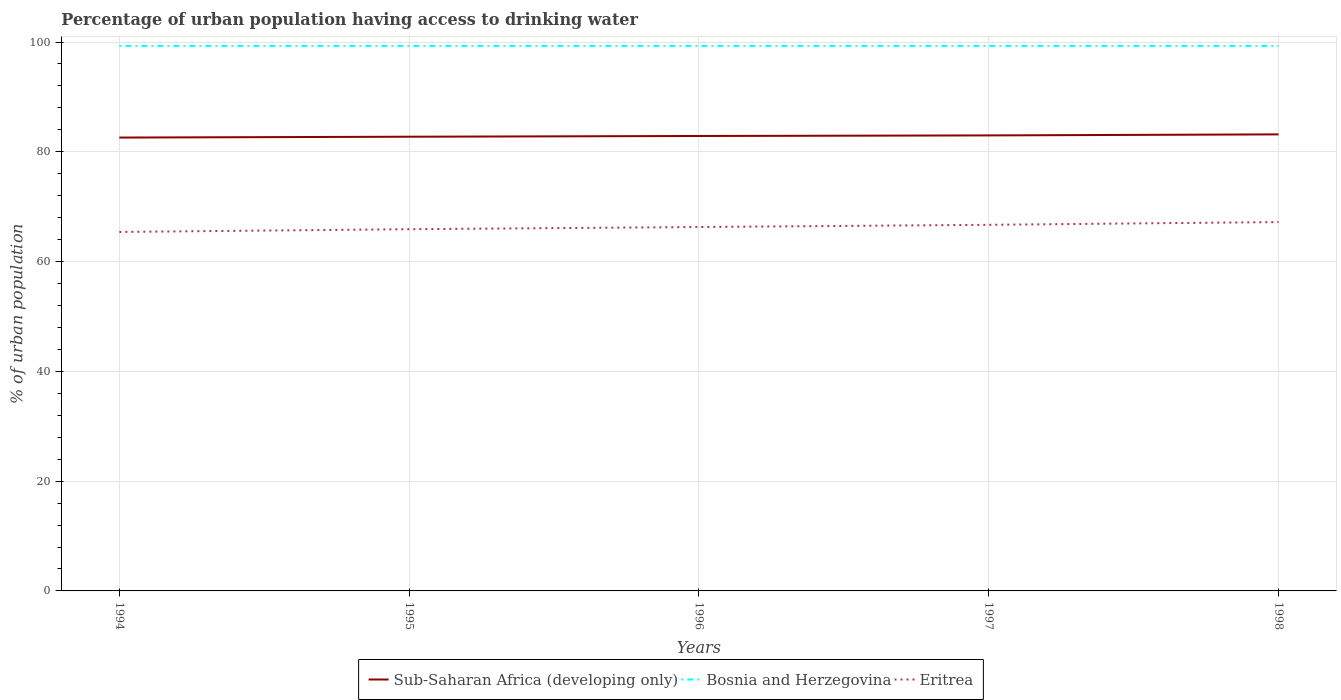How many different coloured lines are there?
Provide a short and direct response. 3. Does the line corresponding to Sub-Saharan Africa (developing only) intersect with the line corresponding to Bosnia and Herzegovina?
Offer a terse response. No. Across all years, what is the maximum percentage of urban population having access to drinking water in Eritrea?
Your answer should be very brief. 65.4. In which year was the percentage of urban population having access to drinking water in Eritrea maximum?
Offer a very short reply. 1994. What is the total percentage of urban population having access to drinking water in Eritrea in the graph?
Ensure brevity in your answer.  -1.3. What is the difference between the highest and the second highest percentage of urban population having access to drinking water in Bosnia and Herzegovina?
Provide a succinct answer. 0. How many years are there in the graph?
Keep it short and to the point. 5. What is the difference between two consecutive major ticks on the Y-axis?
Provide a short and direct response. 20. Are the values on the major ticks of Y-axis written in scientific E-notation?
Your response must be concise. No. Does the graph contain any zero values?
Offer a terse response. No. Where does the legend appear in the graph?
Your response must be concise. Bottom center. What is the title of the graph?
Offer a very short reply. Percentage of urban population having access to drinking water. Does "Sub-Saharan Africa (all income levels)" appear as one of the legend labels in the graph?
Give a very brief answer. No. What is the label or title of the X-axis?
Offer a terse response. Years. What is the label or title of the Y-axis?
Make the answer very short. % of urban population. What is the % of urban population in Sub-Saharan Africa (developing only) in 1994?
Your response must be concise. 82.6. What is the % of urban population of Bosnia and Herzegovina in 1994?
Your answer should be compact. 99.3. What is the % of urban population in Eritrea in 1994?
Offer a very short reply. 65.4. What is the % of urban population in Sub-Saharan Africa (developing only) in 1995?
Offer a terse response. 82.75. What is the % of urban population in Bosnia and Herzegovina in 1995?
Ensure brevity in your answer.  99.3. What is the % of urban population in Eritrea in 1995?
Offer a terse response. 65.9. What is the % of urban population of Sub-Saharan Africa (developing only) in 1996?
Provide a succinct answer. 82.88. What is the % of urban population of Bosnia and Herzegovina in 1996?
Offer a very short reply. 99.3. What is the % of urban population in Eritrea in 1996?
Offer a terse response. 66.3. What is the % of urban population of Sub-Saharan Africa (developing only) in 1997?
Give a very brief answer. 82.99. What is the % of urban population in Bosnia and Herzegovina in 1997?
Give a very brief answer. 99.3. What is the % of urban population of Eritrea in 1997?
Offer a terse response. 66.7. What is the % of urban population of Sub-Saharan Africa (developing only) in 1998?
Your response must be concise. 83.18. What is the % of urban population of Bosnia and Herzegovina in 1998?
Provide a short and direct response. 99.3. What is the % of urban population in Eritrea in 1998?
Make the answer very short. 67.2. Across all years, what is the maximum % of urban population of Sub-Saharan Africa (developing only)?
Offer a terse response. 83.18. Across all years, what is the maximum % of urban population of Bosnia and Herzegovina?
Your answer should be compact. 99.3. Across all years, what is the maximum % of urban population of Eritrea?
Provide a succinct answer. 67.2. Across all years, what is the minimum % of urban population of Sub-Saharan Africa (developing only)?
Ensure brevity in your answer.  82.6. Across all years, what is the minimum % of urban population of Bosnia and Herzegovina?
Provide a short and direct response. 99.3. Across all years, what is the minimum % of urban population of Eritrea?
Offer a very short reply. 65.4. What is the total % of urban population of Sub-Saharan Africa (developing only) in the graph?
Keep it short and to the point. 414.4. What is the total % of urban population of Bosnia and Herzegovina in the graph?
Provide a short and direct response. 496.5. What is the total % of urban population in Eritrea in the graph?
Provide a short and direct response. 331.5. What is the difference between the % of urban population in Sub-Saharan Africa (developing only) in 1994 and that in 1995?
Ensure brevity in your answer.  -0.15. What is the difference between the % of urban population of Bosnia and Herzegovina in 1994 and that in 1995?
Your answer should be very brief. 0. What is the difference between the % of urban population in Sub-Saharan Africa (developing only) in 1994 and that in 1996?
Offer a very short reply. -0.29. What is the difference between the % of urban population in Bosnia and Herzegovina in 1994 and that in 1996?
Make the answer very short. 0. What is the difference between the % of urban population in Sub-Saharan Africa (developing only) in 1994 and that in 1997?
Offer a terse response. -0.39. What is the difference between the % of urban population of Bosnia and Herzegovina in 1994 and that in 1997?
Give a very brief answer. 0. What is the difference between the % of urban population of Eritrea in 1994 and that in 1997?
Provide a short and direct response. -1.3. What is the difference between the % of urban population of Sub-Saharan Africa (developing only) in 1994 and that in 1998?
Keep it short and to the point. -0.58. What is the difference between the % of urban population in Bosnia and Herzegovina in 1994 and that in 1998?
Ensure brevity in your answer.  0. What is the difference between the % of urban population of Sub-Saharan Africa (developing only) in 1995 and that in 1996?
Provide a short and direct response. -0.13. What is the difference between the % of urban population of Bosnia and Herzegovina in 1995 and that in 1996?
Keep it short and to the point. 0. What is the difference between the % of urban population in Sub-Saharan Africa (developing only) in 1995 and that in 1997?
Offer a terse response. -0.24. What is the difference between the % of urban population in Sub-Saharan Africa (developing only) in 1995 and that in 1998?
Keep it short and to the point. -0.43. What is the difference between the % of urban population in Sub-Saharan Africa (developing only) in 1996 and that in 1997?
Keep it short and to the point. -0.1. What is the difference between the % of urban population in Bosnia and Herzegovina in 1996 and that in 1997?
Provide a short and direct response. 0. What is the difference between the % of urban population in Eritrea in 1996 and that in 1997?
Your answer should be compact. -0.4. What is the difference between the % of urban population in Sub-Saharan Africa (developing only) in 1996 and that in 1998?
Ensure brevity in your answer.  -0.29. What is the difference between the % of urban population in Bosnia and Herzegovina in 1996 and that in 1998?
Make the answer very short. 0. What is the difference between the % of urban population in Eritrea in 1996 and that in 1998?
Ensure brevity in your answer.  -0.9. What is the difference between the % of urban population of Sub-Saharan Africa (developing only) in 1997 and that in 1998?
Your response must be concise. -0.19. What is the difference between the % of urban population of Bosnia and Herzegovina in 1997 and that in 1998?
Offer a terse response. 0. What is the difference between the % of urban population of Eritrea in 1997 and that in 1998?
Ensure brevity in your answer.  -0.5. What is the difference between the % of urban population of Sub-Saharan Africa (developing only) in 1994 and the % of urban population of Bosnia and Herzegovina in 1995?
Offer a terse response. -16.7. What is the difference between the % of urban population in Sub-Saharan Africa (developing only) in 1994 and the % of urban population in Eritrea in 1995?
Provide a short and direct response. 16.7. What is the difference between the % of urban population of Bosnia and Herzegovina in 1994 and the % of urban population of Eritrea in 1995?
Offer a very short reply. 33.4. What is the difference between the % of urban population of Sub-Saharan Africa (developing only) in 1994 and the % of urban population of Bosnia and Herzegovina in 1996?
Offer a terse response. -16.7. What is the difference between the % of urban population of Sub-Saharan Africa (developing only) in 1994 and the % of urban population of Eritrea in 1996?
Provide a succinct answer. 16.3. What is the difference between the % of urban population of Sub-Saharan Africa (developing only) in 1994 and the % of urban population of Bosnia and Herzegovina in 1997?
Make the answer very short. -16.7. What is the difference between the % of urban population in Sub-Saharan Africa (developing only) in 1994 and the % of urban population in Eritrea in 1997?
Offer a terse response. 15.9. What is the difference between the % of urban population in Bosnia and Herzegovina in 1994 and the % of urban population in Eritrea in 1997?
Your response must be concise. 32.6. What is the difference between the % of urban population of Sub-Saharan Africa (developing only) in 1994 and the % of urban population of Bosnia and Herzegovina in 1998?
Provide a short and direct response. -16.7. What is the difference between the % of urban population in Sub-Saharan Africa (developing only) in 1994 and the % of urban population in Eritrea in 1998?
Your response must be concise. 15.4. What is the difference between the % of urban population in Bosnia and Herzegovina in 1994 and the % of urban population in Eritrea in 1998?
Your answer should be very brief. 32.1. What is the difference between the % of urban population in Sub-Saharan Africa (developing only) in 1995 and the % of urban population in Bosnia and Herzegovina in 1996?
Your answer should be very brief. -16.55. What is the difference between the % of urban population in Sub-Saharan Africa (developing only) in 1995 and the % of urban population in Eritrea in 1996?
Offer a very short reply. 16.45. What is the difference between the % of urban population in Bosnia and Herzegovina in 1995 and the % of urban population in Eritrea in 1996?
Provide a succinct answer. 33. What is the difference between the % of urban population in Sub-Saharan Africa (developing only) in 1995 and the % of urban population in Bosnia and Herzegovina in 1997?
Offer a terse response. -16.55. What is the difference between the % of urban population of Sub-Saharan Africa (developing only) in 1995 and the % of urban population of Eritrea in 1997?
Provide a succinct answer. 16.05. What is the difference between the % of urban population in Bosnia and Herzegovina in 1995 and the % of urban population in Eritrea in 1997?
Give a very brief answer. 32.6. What is the difference between the % of urban population in Sub-Saharan Africa (developing only) in 1995 and the % of urban population in Bosnia and Herzegovina in 1998?
Make the answer very short. -16.55. What is the difference between the % of urban population in Sub-Saharan Africa (developing only) in 1995 and the % of urban population in Eritrea in 1998?
Your answer should be compact. 15.55. What is the difference between the % of urban population in Bosnia and Herzegovina in 1995 and the % of urban population in Eritrea in 1998?
Your response must be concise. 32.1. What is the difference between the % of urban population of Sub-Saharan Africa (developing only) in 1996 and the % of urban population of Bosnia and Herzegovina in 1997?
Your answer should be compact. -16.42. What is the difference between the % of urban population of Sub-Saharan Africa (developing only) in 1996 and the % of urban population of Eritrea in 1997?
Make the answer very short. 16.18. What is the difference between the % of urban population of Bosnia and Herzegovina in 1996 and the % of urban population of Eritrea in 1997?
Your response must be concise. 32.6. What is the difference between the % of urban population in Sub-Saharan Africa (developing only) in 1996 and the % of urban population in Bosnia and Herzegovina in 1998?
Provide a succinct answer. -16.42. What is the difference between the % of urban population in Sub-Saharan Africa (developing only) in 1996 and the % of urban population in Eritrea in 1998?
Provide a succinct answer. 15.68. What is the difference between the % of urban population in Bosnia and Herzegovina in 1996 and the % of urban population in Eritrea in 1998?
Provide a short and direct response. 32.1. What is the difference between the % of urban population of Sub-Saharan Africa (developing only) in 1997 and the % of urban population of Bosnia and Herzegovina in 1998?
Provide a short and direct response. -16.31. What is the difference between the % of urban population of Sub-Saharan Africa (developing only) in 1997 and the % of urban population of Eritrea in 1998?
Provide a succinct answer. 15.79. What is the difference between the % of urban population of Bosnia and Herzegovina in 1997 and the % of urban population of Eritrea in 1998?
Your response must be concise. 32.1. What is the average % of urban population of Sub-Saharan Africa (developing only) per year?
Provide a short and direct response. 82.88. What is the average % of urban population of Bosnia and Herzegovina per year?
Offer a terse response. 99.3. What is the average % of urban population in Eritrea per year?
Keep it short and to the point. 66.3. In the year 1994, what is the difference between the % of urban population in Sub-Saharan Africa (developing only) and % of urban population in Bosnia and Herzegovina?
Offer a very short reply. -16.7. In the year 1994, what is the difference between the % of urban population of Sub-Saharan Africa (developing only) and % of urban population of Eritrea?
Make the answer very short. 17.2. In the year 1994, what is the difference between the % of urban population in Bosnia and Herzegovina and % of urban population in Eritrea?
Offer a very short reply. 33.9. In the year 1995, what is the difference between the % of urban population of Sub-Saharan Africa (developing only) and % of urban population of Bosnia and Herzegovina?
Your answer should be very brief. -16.55. In the year 1995, what is the difference between the % of urban population of Sub-Saharan Africa (developing only) and % of urban population of Eritrea?
Ensure brevity in your answer.  16.85. In the year 1995, what is the difference between the % of urban population in Bosnia and Herzegovina and % of urban population in Eritrea?
Your answer should be very brief. 33.4. In the year 1996, what is the difference between the % of urban population of Sub-Saharan Africa (developing only) and % of urban population of Bosnia and Herzegovina?
Your answer should be compact. -16.42. In the year 1996, what is the difference between the % of urban population in Sub-Saharan Africa (developing only) and % of urban population in Eritrea?
Ensure brevity in your answer.  16.58. In the year 1997, what is the difference between the % of urban population of Sub-Saharan Africa (developing only) and % of urban population of Bosnia and Herzegovina?
Provide a succinct answer. -16.31. In the year 1997, what is the difference between the % of urban population of Sub-Saharan Africa (developing only) and % of urban population of Eritrea?
Your response must be concise. 16.29. In the year 1997, what is the difference between the % of urban population in Bosnia and Herzegovina and % of urban population in Eritrea?
Give a very brief answer. 32.6. In the year 1998, what is the difference between the % of urban population of Sub-Saharan Africa (developing only) and % of urban population of Bosnia and Herzegovina?
Your response must be concise. -16.12. In the year 1998, what is the difference between the % of urban population of Sub-Saharan Africa (developing only) and % of urban population of Eritrea?
Your answer should be very brief. 15.98. In the year 1998, what is the difference between the % of urban population of Bosnia and Herzegovina and % of urban population of Eritrea?
Ensure brevity in your answer.  32.1. What is the ratio of the % of urban population of Sub-Saharan Africa (developing only) in 1994 to that in 1995?
Offer a terse response. 1. What is the ratio of the % of urban population of Bosnia and Herzegovina in 1994 to that in 1995?
Your answer should be compact. 1. What is the ratio of the % of urban population in Eritrea in 1994 to that in 1995?
Offer a terse response. 0.99. What is the ratio of the % of urban population in Sub-Saharan Africa (developing only) in 1994 to that in 1996?
Ensure brevity in your answer.  1. What is the ratio of the % of urban population in Bosnia and Herzegovina in 1994 to that in 1996?
Offer a terse response. 1. What is the ratio of the % of urban population of Eritrea in 1994 to that in 1996?
Your response must be concise. 0.99. What is the ratio of the % of urban population of Sub-Saharan Africa (developing only) in 1994 to that in 1997?
Provide a succinct answer. 1. What is the ratio of the % of urban population of Eritrea in 1994 to that in 1997?
Give a very brief answer. 0.98. What is the ratio of the % of urban population of Bosnia and Herzegovina in 1994 to that in 1998?
Your answer should be very brief. 1. What is the ratio of the % of urban population in Eritrea in 1994 to that in 1998?
Your answer should be very brief. 0.97. What is the ratio of the % of urban population of Sub-Saharan Africa (developing only) in 1995 to that in 1996?
Keep it short and to the point. 1. What is the ratio of the % of urban population of Bosnia and Herzegovina in 1995 to that in 1996?
Your response must be concise. 1. What is the ratio of the % of urban population in Sub-Saharan Africa (developing only) in 1995 to that in 1997?
Offer a terse response. 1. What is the ratio of the % of urban population of Bosnia and Herzegovina in 1995 to that in 1997?
Your response must be concise. 1. What is the ratio of the % of urban population of Sub-Saharan Africa (developing only) in 1995 to that in 1998?
Give a very brief answer. 0.99. What is the ratio of the % of urban population of Eritrea in 1995 to that in 1998?
Offer a terse response. 0.98. What is the ratio of the % of urban population in Sub-Saharan Africa (developing only) in 1996 to that in 1997?
Offer a terse response. 1. What is the ratio of the % of urban population of Eritrea in 1996 to that in 1997?
Offer a terse response. 0.99. What is the ratio of the % of urban population of Sub-Saharan Africa (developing only) in 1996 to that in 1998?
Offer a very short reply. 1. What is the ratio of the % of urban population in Eritrea in 1996 to that in 1998?
Offer a very short reply. 0.99. What is the ratio of the % of urban population in Sub-Saharan Africa (developing only) in 1997 to that in 1998?
Make the answer very short. 1. What is the ratio of the % of urban population in Bosnia and Herzegovina in 1997 to that in 1998?
Keep it short and to the point. 1. What is the ratio of the % of urban population in Eritrea in 1997 to that in 1998?
Your answer should be very brief. 0.99. What is the difference between the highest and the second highest % of urban population of Sub-Saharan Africa (developing only)?
Give a very brief answer. 0.19. What is the difference between the highest and the second highest % of urban population of Eritrea?
Provide a short and direct response. 0.5. What is the difference between the highest and the lowest % of urban population in Sub-Saharan Africa (developing only)?
Your answer should be very brief. 0.58. What is the difference between the highest and the lowest % of urban population in Bosnia and Herzegovina?
Your answer should be very brief. 0. What is the difference between the highest and the lowest % of urban population of Eritrea?
Offer a very short reply. 1.8. 